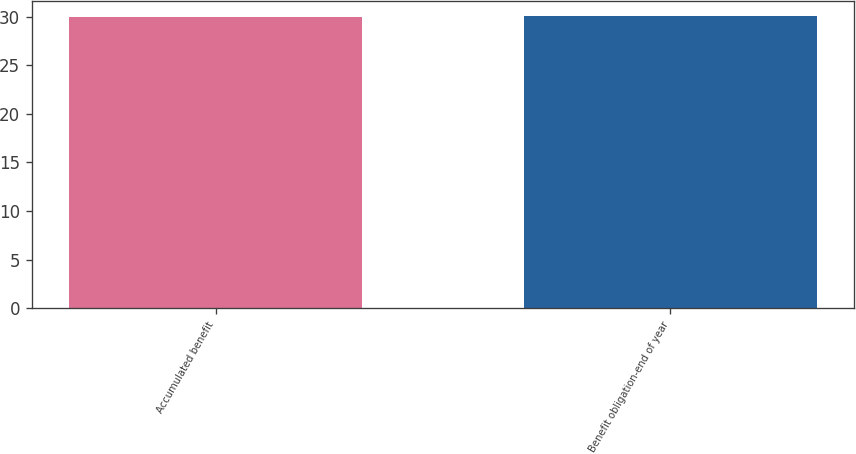Convert chart. <chart><loc_0><loc_0><loc_500><loc_500><bar_chart><fcel>Accumulated benefit<fcel>Benefit obligation-end of year<nl><fcel>30<fcel>30.1<nl></chart> 